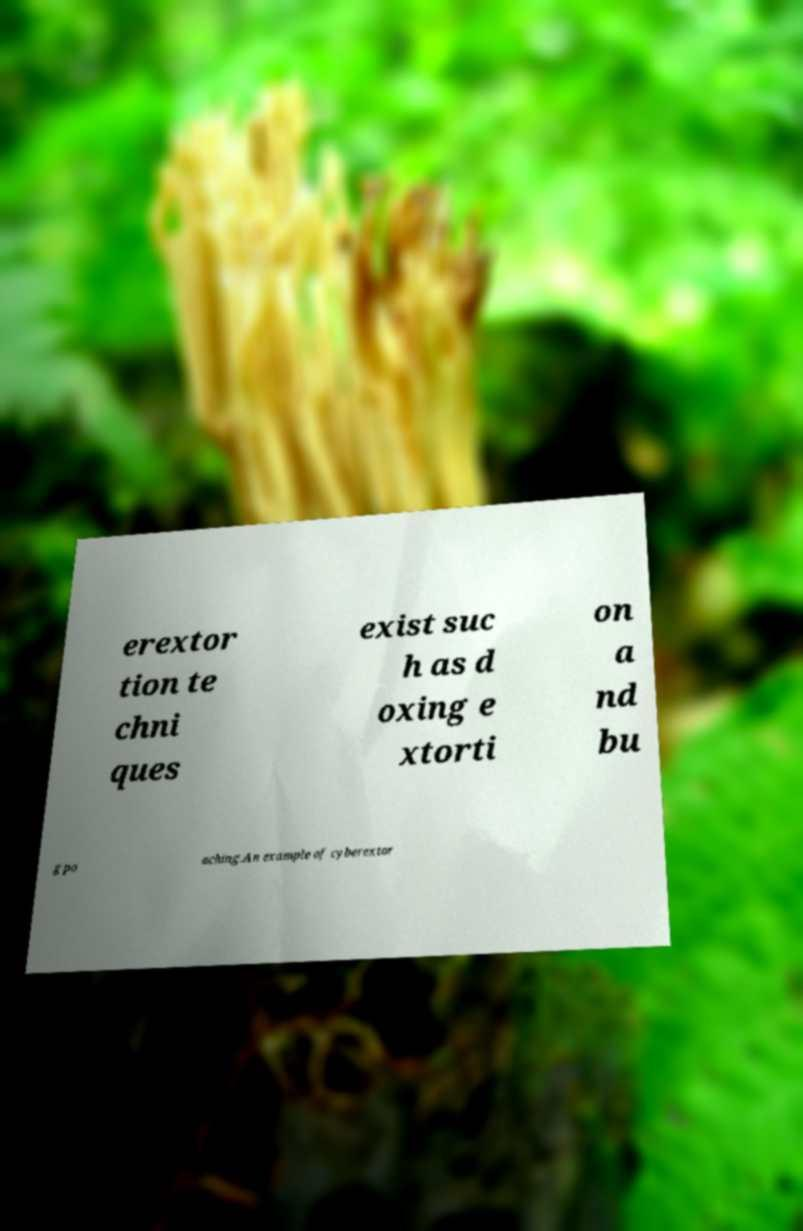Can you read and provide the text displayed in the image?This photo seems to have some interesting text. Can you extract and type it out for me? erextor tion te chni ques exist suc h as d oxing e xtorti on a nd bu g po aching.An example of cyberextor 